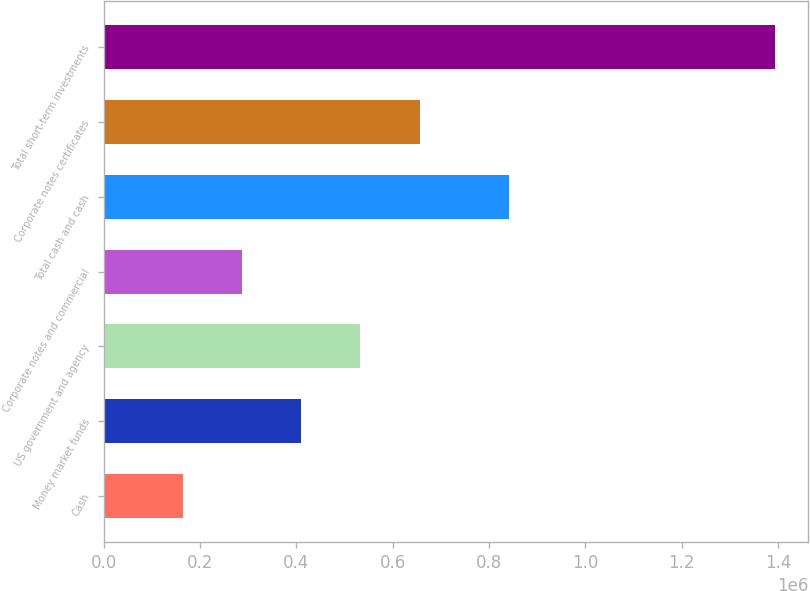<chart> <loc_0><loc_0><loc_500><loc_500><bar_chart><fcel>Cash<fcel>Money market funds<fcel>US government and agency<fcel>Corporate notes and commercial<fcel>Total cash and cash<fcel>Corporate notes certificates<fcel>Total short-term investments<nl><fcel>164135<fcel>409917<fcel>532808<fcel>287026<fcel>841010<fcel>655699<fcel>1.39304e+06<nl></chart> 